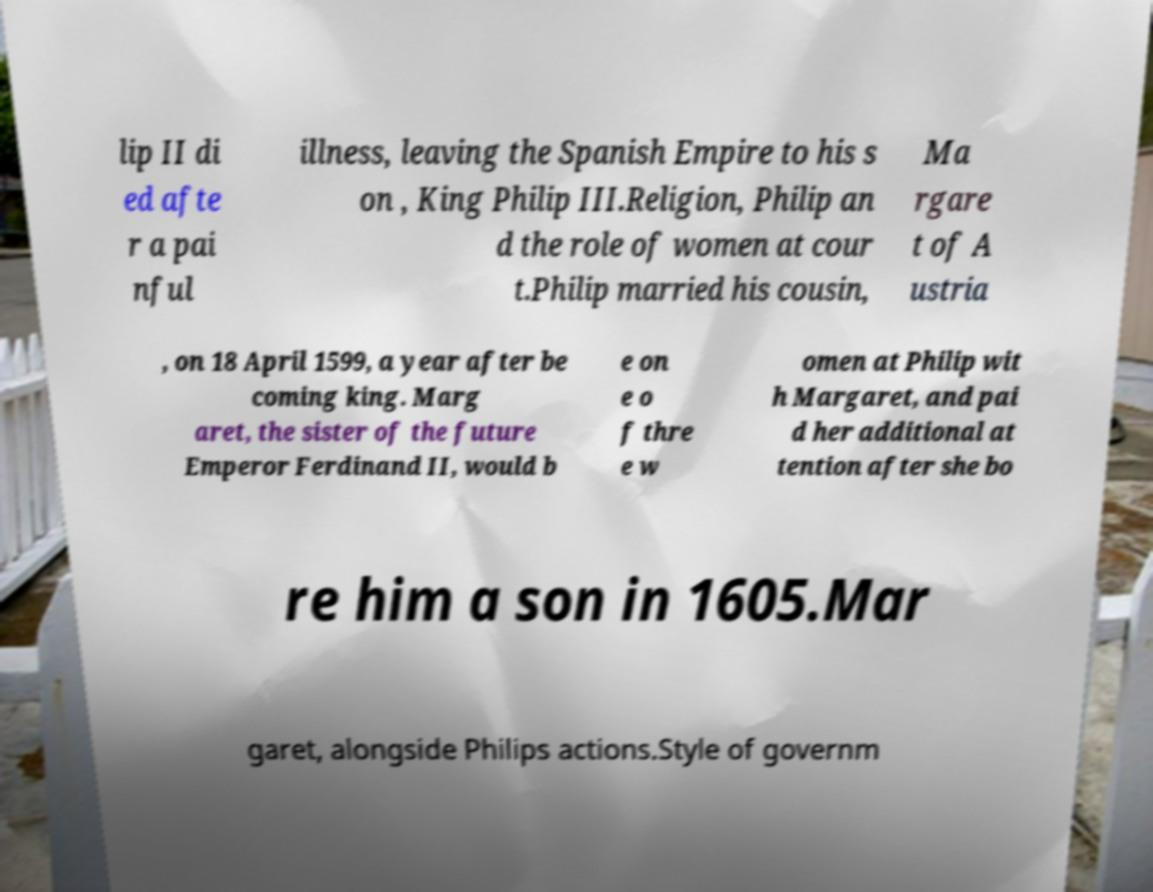Could you extract and type out the text from this image? lip II di ed afte r a pai nful illness, leaving the Spanish Empire to his s on , King Philip III.Religion, Philip an d the role of women at cour t.Philip married his cousin, Ma rgare t of A ustria , on 18 April 1599, a year after be coming king. Marg aret, the sister of the future Emperor Ferdinand II, would b e on e o f thre e w omen at Philip wit h Margaret, and pai d her additional at tention after she bo re him a son in 1605.Mar garet, alongside Philips actions.Style of governm 